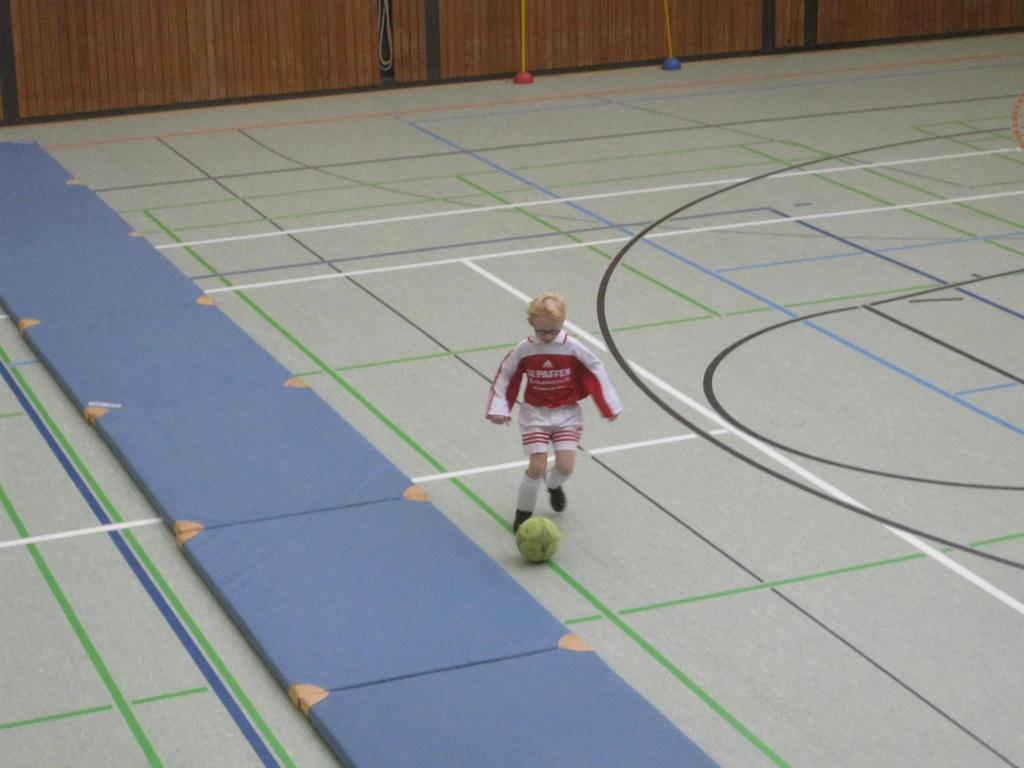What does it say on his shirt?
Make the answer very short. Paffen. What color is the text on his shirt?
Make the answer very short. Answering does not require reading text in the image. 